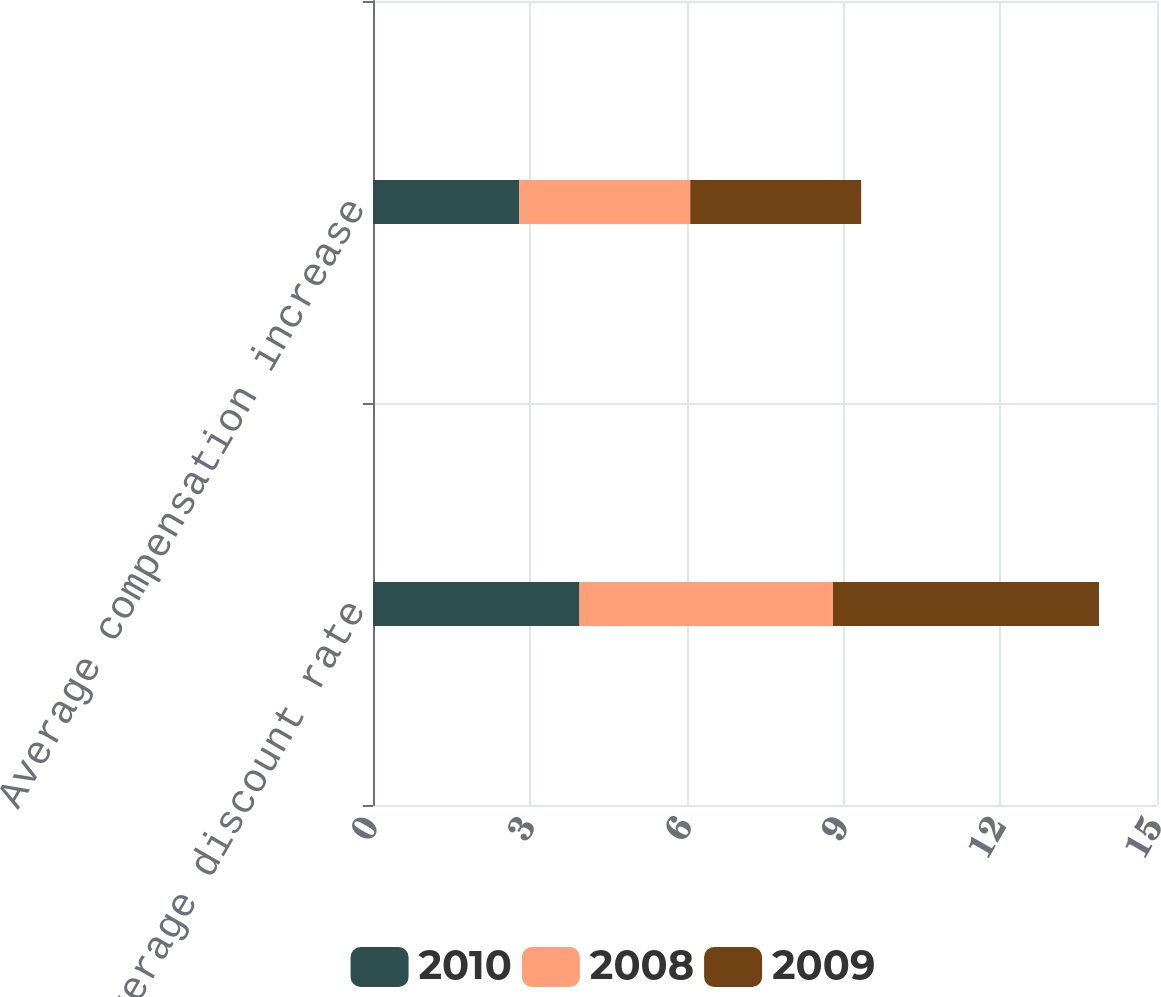Convert chart to OTSL. <chart><loc_0><loc_0><loc_500><loc_500><stacked_bar_chart><ecel><fcel>Weighted-average discount rate<fcel>Average compensation increase<nl><fcel>2010<fcel>3.95<fcel>2.8<nl><fcel>2008<fcel>4.85<fcel>3.27<nl><fcel>2009<fcel>5.09<fcel>3.27<nl></chart> 